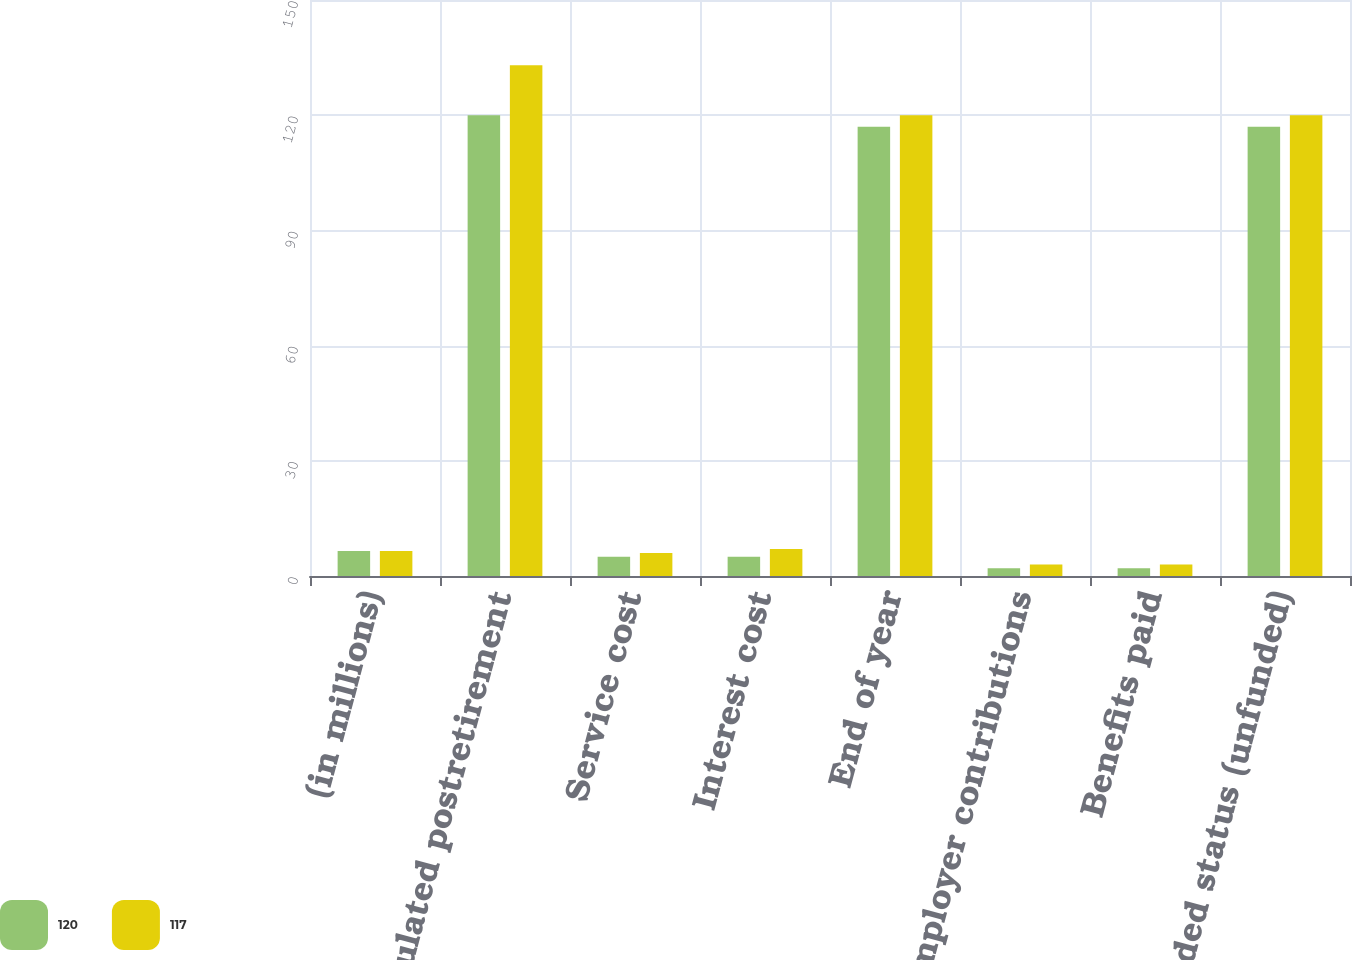Convert chart. <chart><loc_0><loc_0><loc_500><loc_500><stacked_bar_chart><ecel><fcel>(in millions)<fcel>Accumulated postretirement<fcel>Service cost<fcel>Interest cost<fcel>End of year<fcel>Employer contributions<fcel>Benefits paid<fcel>Funded status (unfunded)<nl><fcel>120<fcel>6.5<fcel>120<fcel>5<fcel>5<fcel>117<fcel>2<fcel>2<fcel>117<nl><fcel>117<fcel>6.5<fcel>133<fcel>6<fcel>7<fcel>120<fcel>3<fcel>3<fcel>120<nl></chart> 